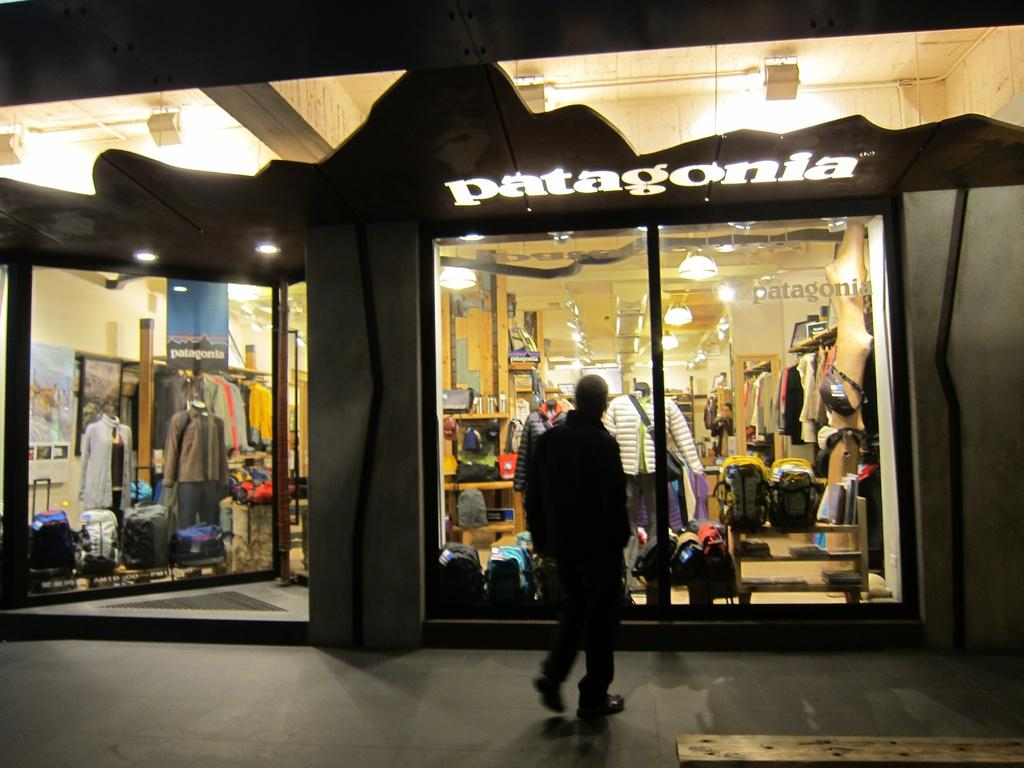What is the person in the image doing? The person is standing in front of a window. What type of store does the window belong to? The window belongs to an apparel store. What items can be seen on display in the store? The apparel store has clothes and bags on display. What can be seen on the ceiling in the image? There are lights on the ceiling in the image. How many beds are visible in the image? There are no beds present in the image. What shape is the calculator on the window display? There is no calculator visible in the image. 